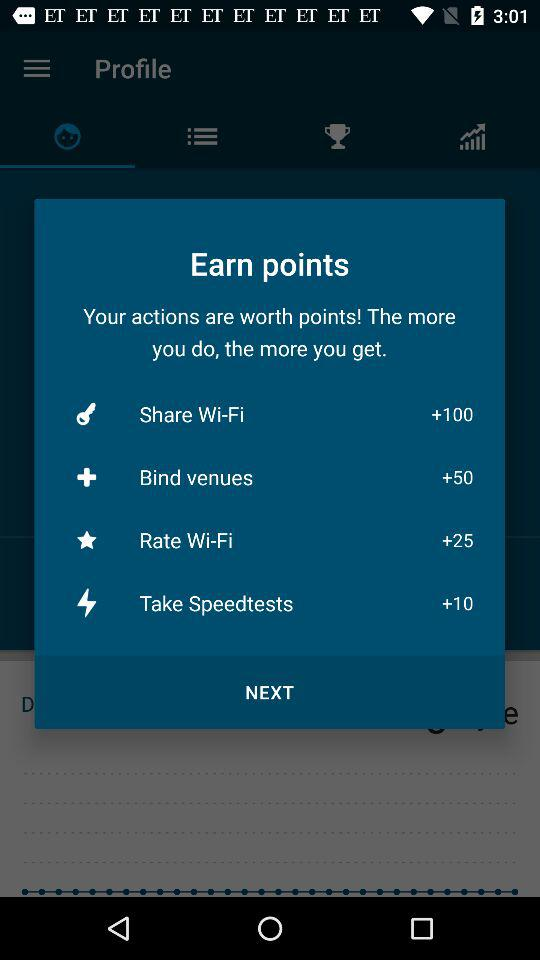What might be the purpose of these points? Points like these are typically part of a user engagement or loyalty program. They can be used to track user participation, incentivize desired behaviors, or be exchanged for rewards, such as discounts, services, or even physical goods, depending on the app's offerings and partnerships. 